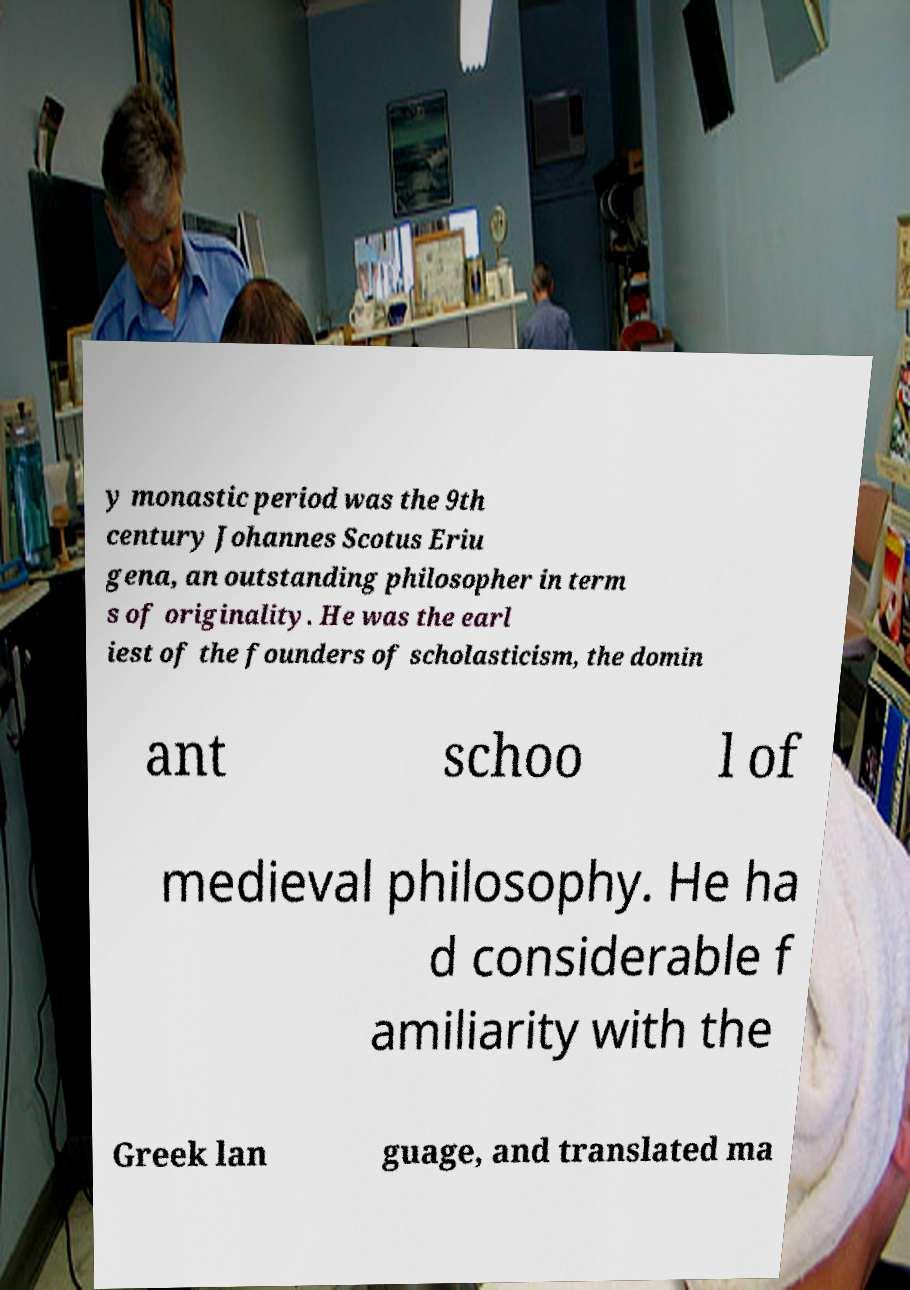Could you assist in decoding the text presented in this image and type it out clearly? y monastic period was the 9th century Johannes Scotus Eriu gena, an outstanding philosopher in term s of originality. He was the earl iest of the founders of scholasticism, the domin ant schoo l of medieval philosophy. He ha d considerable f amiliarity with the Greek lan guage, and translated ma 